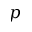Convert formula to latex. <formula><loc_0><loc_0><loc_500><loc_500>p</formula> 